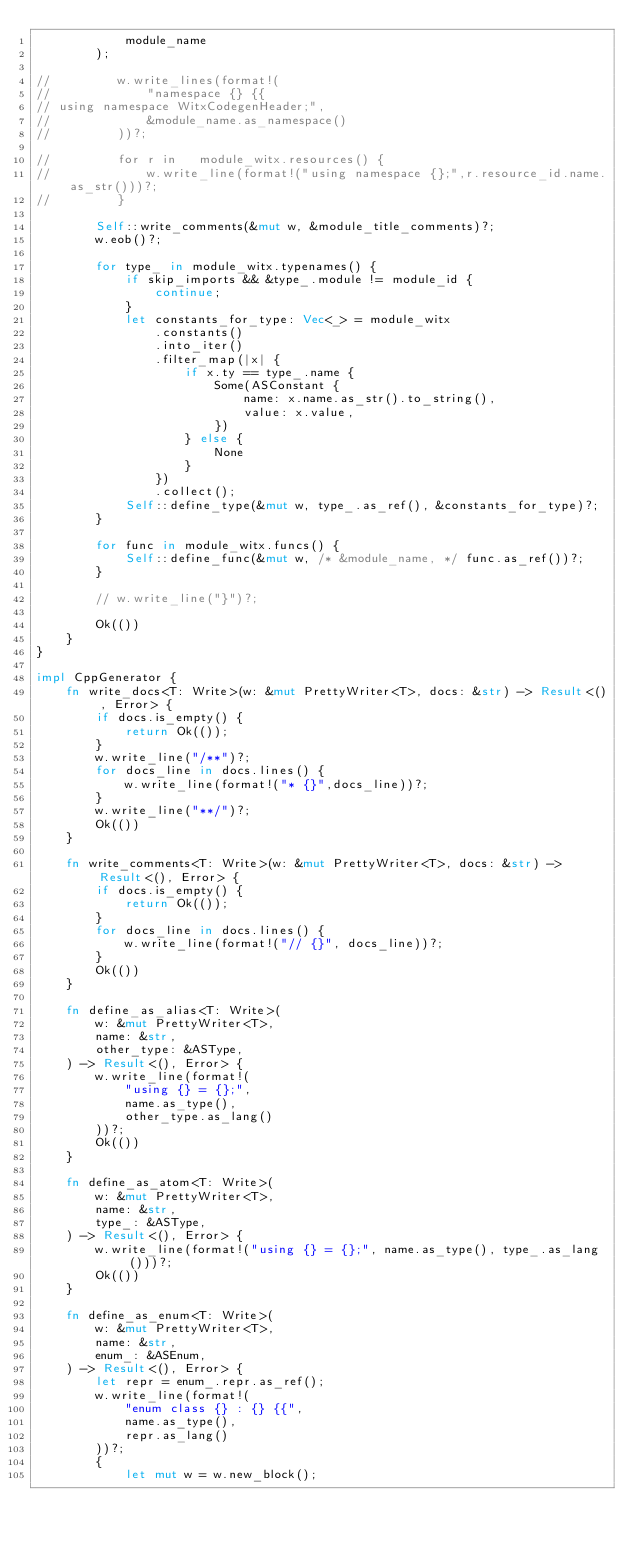<code> <loc_0><loc_0><loc_500><loc_500><_Rust_>            module_name
        );

//         w.write_lines(format!(
//             "namespace {} {{
// using namespace WitxCodegenHeader;",
//             &module_name.as_namespace()
//         ))?;

//         for r in   module_witx.resources() {
//             w.write_line(format!("using namespace {};",r.resource_id.name.as_str()))?;
//         }

        Self::write_comments(&mut w, &module_title_comments)?;
        w.eob()?;

        for type_ in module_witx.typenames() {
            if skip_imports && &type_.module != module_id {
                continue;
            }
            let constants_for_type: Vec<_> = module_witx
                .constants()
                .into_iter()
                .filter_map(|x| {
                    if x.ty == type_.name {
                        Some(ASConstant {
                            name: x.name.as_str().to_string(),
                            value: x.value,
                        })
                    } else {
                        None
                    }
                })
                .collect();
            Self::define_type(&mut w, type_.as_ref(), &constants_for_type)?;
        }

        for func in module_witx.funcs() {
            Self::define_func(&mut w, /* &module_name, */ func.as_ref())?;
        }

        // w.write_line("}")?;

        Ok(())
    }
}

impl CppGenerator {
    fn write_docs<T: Write>(w: &mut PrettyWriter<T>, docs: &str) -> Result<(), Error> {
        if docs.is_empty() {
            return Ok(());
        }
        w.write_line("/**")?;
        for docs_line in docs.lines() {
            w.write_line(format!("* {}",docs_line))?;
        }
        w.write_line("**/")?;
        Ok(())
    }

    fn write_comments<T: Write>(w: &mut PrettyWriter<T>, docs: &str) -> Result<(), Error> {
        if docs.is_empty() {
            return Ok(());
        }
        for docs_line in docs.lines() {
            w.write_line(format!("// {}", docs_line))?;
        }
        Ok(())
    }

    fn define_as_alias<T: Write>(
        w: &mut PrettyWriter<T>,
        name: &str,
        other_type: &ASType,
    ) -> Result<(), Error> {
        w.write_line(format!(
            "using {} = {};",
            name.as_type(),
            other_type.as_lang()
        ))?;
        Ok(())
    }

    fn define_as_atom<T: Write>(
        w: &mut PrettyWriter<T>,
        name: &str,
        type_: &ASType,
    ) -> Result<(), Error> {
        w.write_line(format!("using {} = {};", name.as_type(), type_.as_lang()))?;
        Ok(())
    }

    fn define_as_enum<T: Write>(
        w: &mut PrettyWriter<T>,
        name: &str,
        enum_: &ASEnum,
    ) -> Result<(), Error> {
        let repr = enum_.repr.as_ref();
        w.write_line(format!(
            "enum class {} : {} {{",
            name.as_type(),
            repr.as_lang()
        ))?;
        {
            let mut w = w.new_block();</code> 